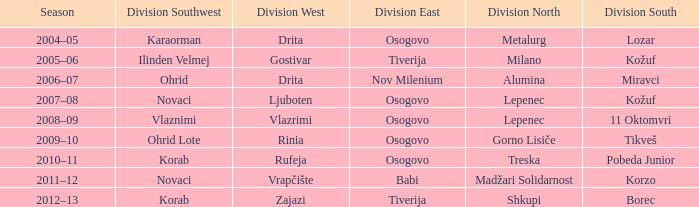Who won Division North when Division Southwest was won by Novaci and Division West by Vrapčište? Madžari Solidarnost. 